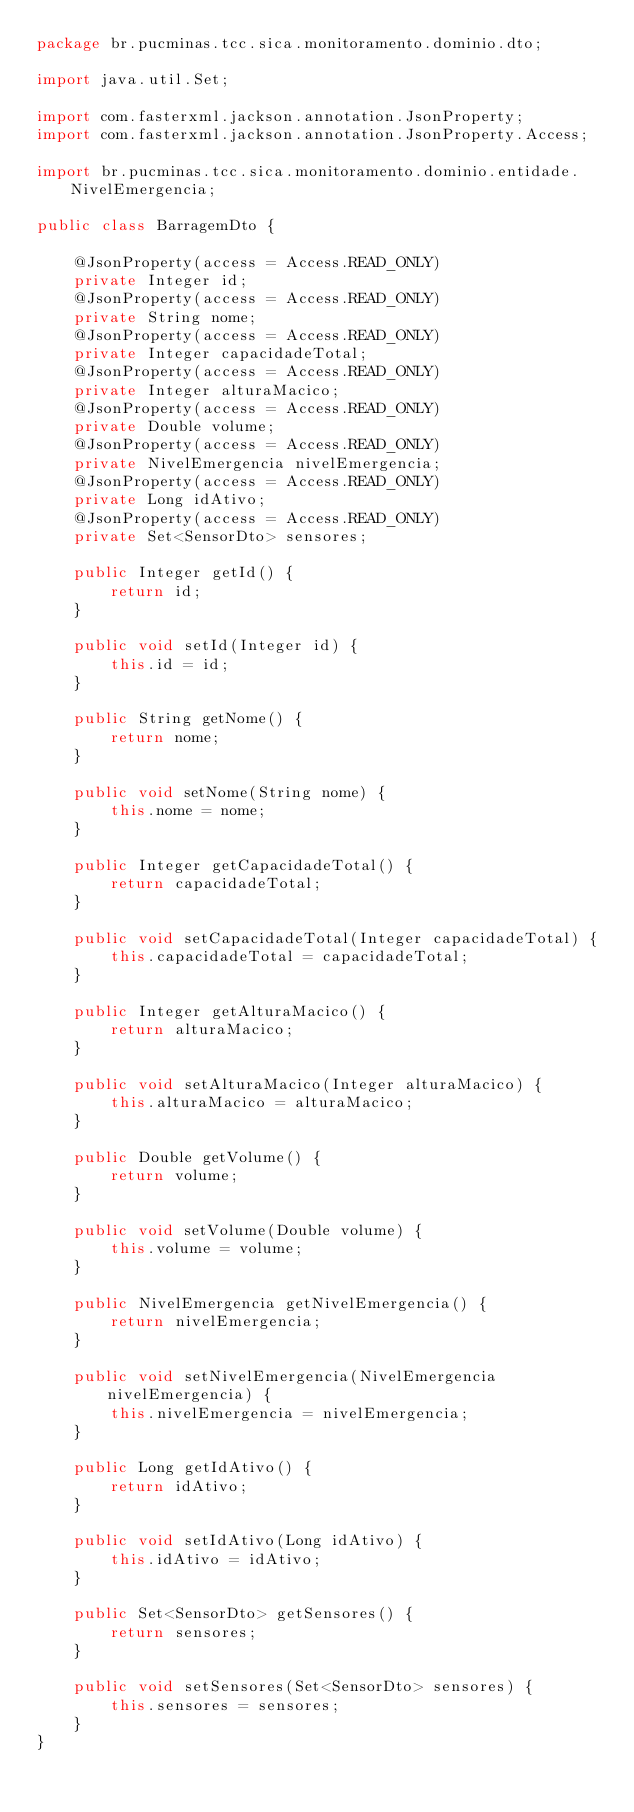Convert code to text. <code><loc_0><loc_0><loc_500><loc_500><_Java_>package br.pucminas.tcc.sica.monitoramento.dominio.dto;

import java.util.Set;

import com.fasterxml.jackson.annotation.JsonProperty;
import com.fasterxml.jackson.annotation.JsonProperty.Access;

import br.pucminas.tcc.sica.monitoramento.dominio.entidade.NivelEmergencia;

public class BarragemDto {

    @JsonProperty(access = Access.READ_ONLY)
    private Integer id;
    @JsonProperty(access = Access.READ_ONLY)
    private String nome;
    @JsonProperty(access = Access.READ_ONLY)
    private Integer capacidadeTotal;
    @JsonProperty(access = Access.READ_ONLY)
    private Integer alturaMacico;
    @JsonProperty(access = Access.READ_ONLY)
    private Double volume;
    @JsonProperty(access = Access.READ_ONLY)
    private NivelEmergencia nivelEmergencia;
    @JsonProperty(access = Access.READ_ONLY)
    private Long idAtivo;
    @JsonProperty(access = Access.READ_ONLY)
    private Set<SensorDto> sensores;

    public Integer getId() {
        return id;
    }

    public void setId(Integer id) {
        this.id = id;
    }

    public String getNome() {
        return nome;
    }

    public void setNome(String nome) {
        this.nome = nome;
    }

    public Integer getCapacidadeTotal() {
        return capacidadeTotal;
    }

    public void setCapacidadeTotal(Integer capacidadeTotal) {
        this.capacidadeTotal = capacidadeTotal;
    }

    public Integer getAlturaMacico() {
        return alturaMacico;
    }

    public void setAlturaMacico(Integer alturaMacico) {
        this.alturaMacico = alturaMacico;
    }

    public Double getVolume() {
        return volume;
    }

    public void setVolume(Double volume) {
        this.volume = volume;
    }

    public NivelEmergencia getNivelEmergencia() {
        return nivelEmergencia;
    }

    public void setNivelEmergencia(NivelEmergencia nivelEmergencia) {
        this.nivelEmergencia = nivelEmergencia;
    }

    public Long getIdAtivo() {
        return idAtivo;
    }

    public void setIdAtivo(Long idAtivo) {
        this.idAtivo = idAtivo;
    }

    public Set<SensorDto> getSensores() {
        return sensores;
    }

    public void setSensores(Set<SensorDto> sensores) {
        this.sensores = sensores;
    }
}
</code> 